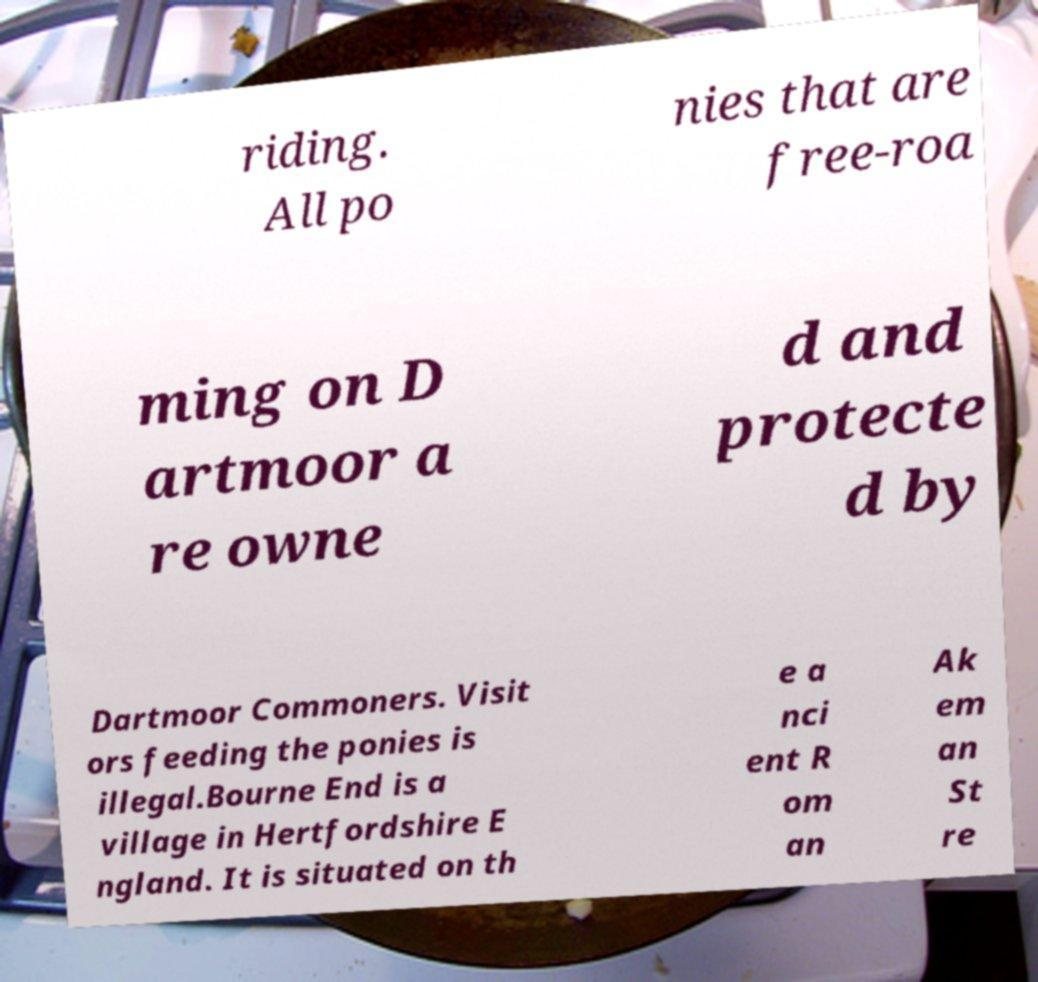What messages or text are displayed in this image? I need them in a readable, typed format. riding. All po nies that are free-roa ming on D artmoor a re owne d and protecte d by Dartmoor Commoners. Visit ors feeding the ponies is illegal.Bourne End is a village in Hertfordshire E ngland. It is situated on th e a nci ent R om an Ak em an St re 